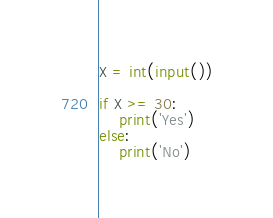<code> <loc_0><loc_0><loc_500><loc_500><_Python_>X = int(input())

if X >= 30:
    print('Yes')
else:
    print('No')</code> 